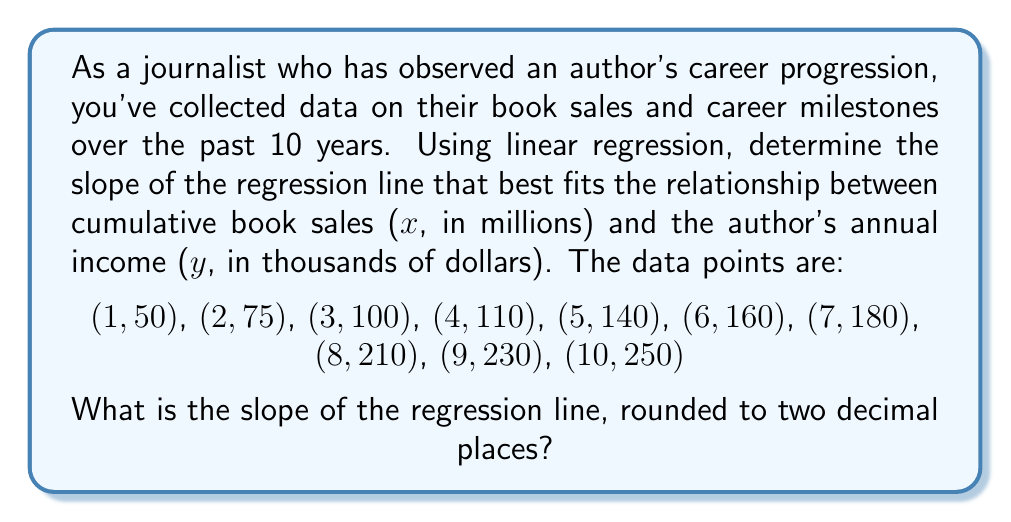Can you answer this question? To find the slope of the regression line, we'll use the formula:

$$ b = \frac{n\sum xy - \sum x \sum y}{n\sum x^2 - (\sum x)^2} $$

Where:
$n$ is the number of data points
$x$ is cumulative book sales in millions
$y$ is annual income in thousands of dollars

Step 1: Calculate the necessary sums:
$n = 10$
$\sum x = 55$
$\sum y = 1505$
$\sum xy = 10,175$
$\sum x^2 = 385$

Step 2: Apply the formula:

$$ b = \frac{10(10,175) - (55)(1505)}{10(385) - (55)^2} $$

Step 3: Simplify:

$$ b = \frac{101,750 - 82,775}{3850 - 3025} $$

$$ b = \frac{18,975}{825} $$

Step 4: Calculate and round to two decimal places:

$$ b = 23.00 $$
Answer: 23.00 